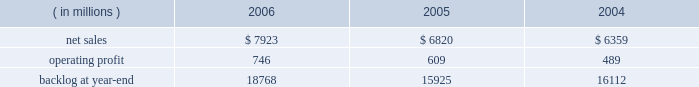Operating profit for the segment increased by 15% ( 15 % ) in 2005 compared to 2004 .
Operating profit increased by $ 80 million at m&fc mainly due to improved performance on fire control and air defense programs .
Performance on surface systems programs contributed to an increase in operating profit of $ 50 million at ms2 .
Pt&ts operating profit increased $ 10 million primarily due to improved performance on simulation and training programs .
The increase in backlog during 2006 over 2005 resulted primarily from increased orders on certain platform integration programs in pt&ts .
Space systems space systems 2019 operating results included the following : ( in millions ) 2006 2005 2004 .
Net sales for space systems increased by 16% ( 16 % ) in 2006 compared to 2005 .
During the year , sales growth in satellites and strategic & defensive missile systems ( s&dms ) offset declines in space transportation .
The $ 1.1 billion growth in satellites sales was mainly due to higher volume on both government and commercial satellite programs .
There were five commercial satellite deliveries in 2006 compared to no deliveries in 2005 .
Higher volume in both fleet ballistic missile and missile defense programs accounted for the $ 114 million sales increase at s&dms .
In space transportation , sales declined $ 102 million primarily due to lower volume in government space transportation activities on the titan and external tank programs .
Increased sales on the atlas evolved expendable launch vehicle launch capabilities ( elc ) contract partially offset the lower government space transportation sales .
Net sales for space systems increased by 7% ( 7 % ) in 2005 compared to 2004 .
During the year , sales growth in satellites and s&dms offset declines in space transportation .
The $ 410 million increase in satellites sales was due to higher volume on government satellite programs that more than offset declines in commercial satellite activities .
There were no commercial satellite deliveries in 2005 , compared to four in 2004 .
Increased sales of $ 235 million in s&dms were attributable to the fleet ballistic missile and missile defense programs .
The $ 180 million decrease in space transportation 2019s sales was mainly due to having three atlas launches in 2005 compared to six in 2004 .
Operating profit for the segment increased 22% ( 22 % ) in 2006 compared to 2005 .
Operating profit increased in satellites , space transportation and s&dms .
The $ 72 million growth in satellites operating profit was primarily driven by the volume and performance on government satellite programs and commercial satellite deliveries .
In space transportation , the $ 39 million growth in operating profit was attributable to improved performance on the atlas program resulting from risk reduction activities , including the first quarter definitization of the elc contract .
In s&dms , the $ 26 million increase in operating profit was due to higher volume and improved performance on both the fleet ballistic missile and missile defense programs .
Operating profit for the segment increased 25% ( 25 % ) in 2005 compared to 2004 .
Operating profit increased in space transportation , s&dms and satellites .
In space transportation , the $ 60 million increase in operating profit was primarily attributable to improved performance on the atlas vehicle program .
Satellites 2019 operating profit increased $ 35 million due to the higher volume and improved performance on government satellite programs , which more than offset the decreased operating profit due to the decline in commercial satellite deliveries .
The $ 20 million increase in s&dms was attributable to higher volume on fleet ballistic missile and missile defense programs .
In december 2006 , we completed a transaction with boeing to form ula , a joint venture which combines the production , engineering , test and launch operations associated with u.s .
Government launches of our atlas launch vehicles and boeing 2019s delta launch vehicles ( see related discussion on our 201cspace business 201d under 201cindustry considerations 201d ) .
We are accounting for our investment in ula under the equity method of accounting .
As a result , our share of the net earnings or losses of ula are included in other income and expenses , and we will no longer recognize sales related to launch vehicle services provided to the u.s .
Government .
In 2006 , we recorded sales to the u.s .
Government for atlas launch services totaling approximately $ 600 million .
We have retained the right to market commercial atlas launch services .
We contributed assets to ula , and ula assumed liabilities related to our atlas business in exchange for our 50% ( 50 % ) ownership interest .
The net book value of the assets contributed and liabilities assumed was approximately $ 200 million at .
What was the ratio of the increase in the operating profit for m&fc to pt&ts? 
Computations: (80 / 10)
Answer: 8.0. 